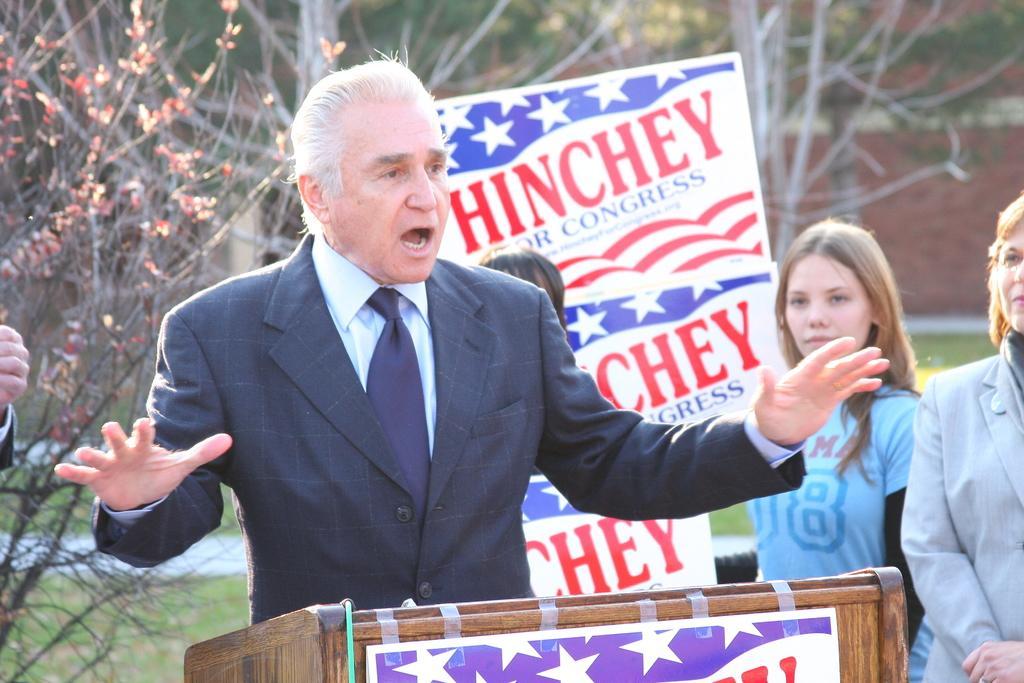Could you give a brief overview of what you see in this image? In this image I can see a person standing in front of the podium. I can see few people,trees,boards and a wall. 